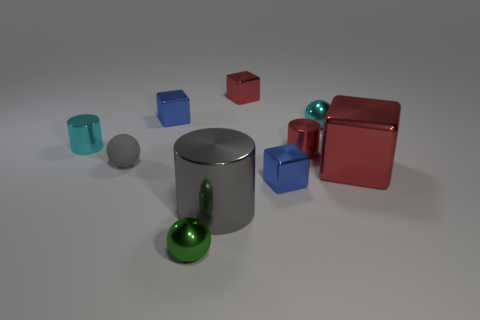Is the color of the large cylinder the same as the tiny matte ball?
Ensure brevity in your answer.  Yes. There is a large cylinder that is the same color as the tiny matte ball; what is its material?
Offer a terse response. Metal. Are there any small metal blocks behind the tiny gray matte ball?
Offer a very short reply. Yes. What number of other objects are there of the same size as the green thing?
Make the answer very short. 7. What is the thing that is in front of the small cyan shiny cylinder and behind the rubber thing made of?
Keep it short and to the point. Metal. Does the small blue metallic object in front of the cyan cylinder have the same shape as the thing to the left of the small gray ball?
Your response must be concise. No. Is there any other thing that is made of the same material as the big red object?
Provide a succinct answer. Yes. There is a blue shiny object right of the tiny shiny ball that is left of the small thing that is on the right side of the red metal cylinder; what shape is it?
Keep it short and to the point. Cube. How many other things are the same shape as the gray rubber thing?
Keep it short and to the point. 2. What is the color of the other metallic ball that is the same size as the green ball?
Your answer should be very brief. Cyan. 